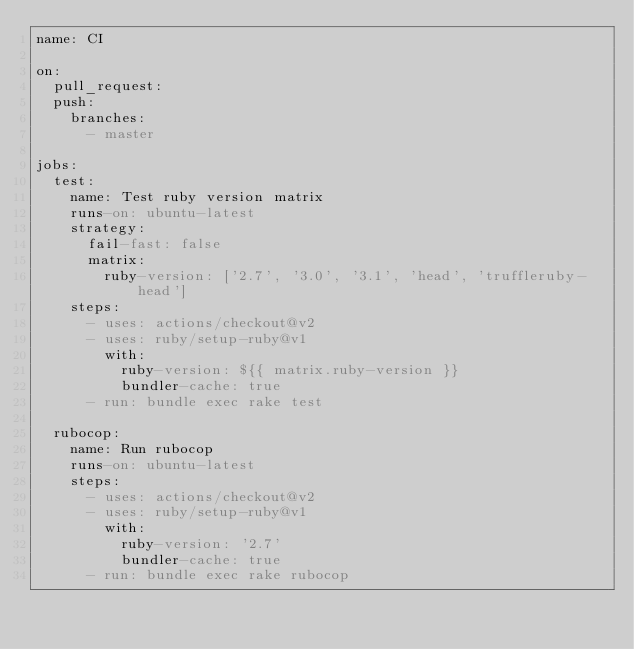Convert code to text. <code><loc_0><loc_0><loc_500><loc_500><_YAML_>name: CI

on:
  pull_request:
  push:
    branches:
      - master

jobs:
  test:
    name: Test ruby version matrix
    runs-on: ubuntu-latest
    strategy:
      fail-fast: false
      matrix:
        ruby-version: ['2.7', '3.0', '3.1', 'head', 'truffleruby-head']
    steps:
      - uses: actions/checkout@v2
      - uses: ruby/setup-ruby@v1
        with:
          ruby-version: ${{ matrix.ruby-version }}
          bundler-cache: true
      - run: bundle exec rake test

  rubocop:
    name: Run rubocop
    runs-on: ubuntu-latest
    steps:
      - uses: actions/checkout@v2
      - uses: ruby/setup-ruby@v1
        with:
          ruby-version: '2.7'
          bundler-cache: true
      - run: bundle exec rake rubocop
</code> 